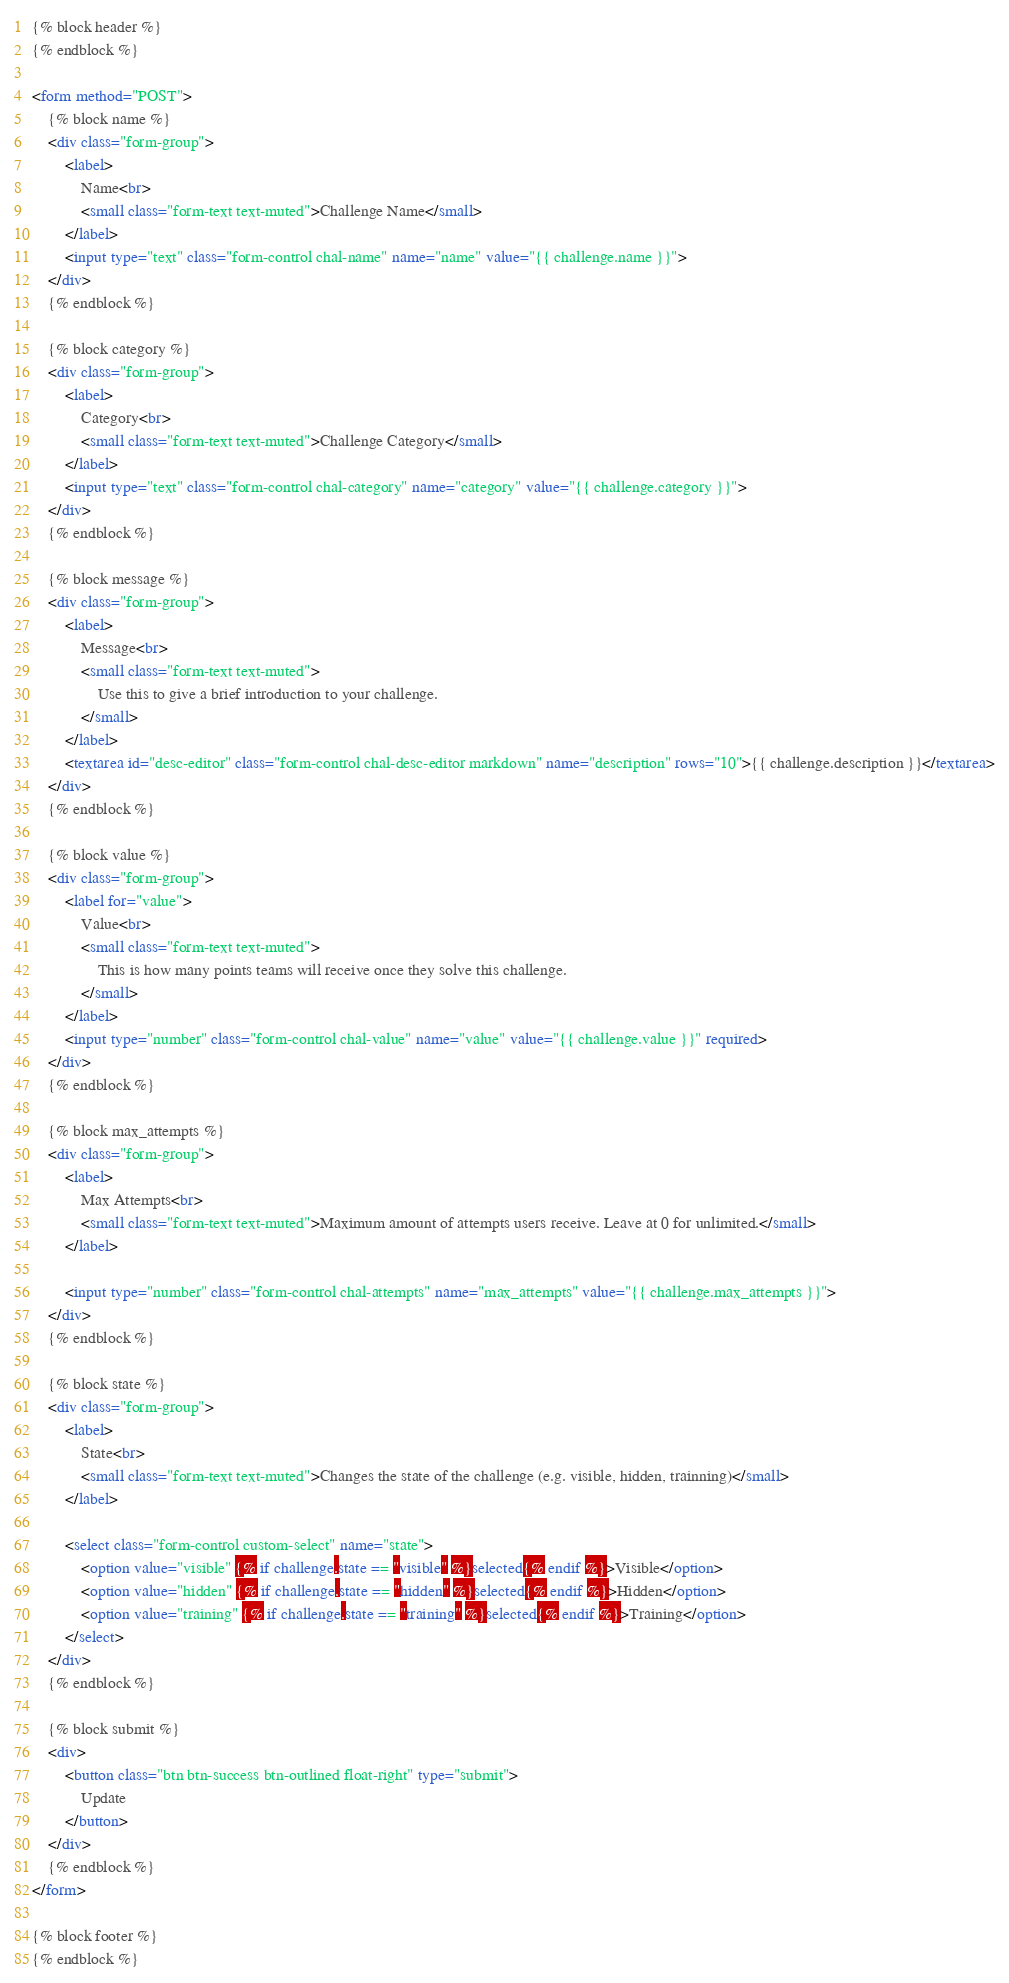Convert code to text. <code><loc_0><loc_0><loc_500><loc_500><_HTML_>{% block header %}
{% endblock %}

<form method="POST">
	{% block name %}
	<div class="form-group">
		<label>
			Name<br>
			<small class="form-text text-muted">Challenge Name</small>
		</label>
		<input type="text" class="form-control chal-name" name="name" value="{{ challenge.name }}">
	</div>
	{% endblock %}

	{% block category %}
	<div class="form-group">
		<label>
			Category<br>
			<small class="form-text text-muted">Challenge Category</small>
		</label>
		<input type="text" class="form-control chal-category" name="category" value="{{ challenge.category }}">
	</div>
	{% endblock %}

	{% block message %}
	<div class="form-group">
		<label>
			Message<br>
			<small class="form-text text-muted">
				Use this to give a brief introduction to your challenge.
			</small>
		</label>
		<textarea id="desc-editor" class="form-control chal-desc-editor markdown" name="description" rows="10">{{ challenge.description }}</textarea>
	</div>
	{% endblock %}

	{% block value %}
	<div class="form-group">
		<label for="value">
			Value<br>
			<small class="form-text text-muted">
				This is how many points teams will receive once they solve this challenge.
			</small>
		</label>
		<input type="number" class="form-control chal-value" name="value" value="{{ challenge.value }}" required>
	</div>
	{% endblock %}

	{% block max_attempts %}
	<div class="form-group">
		<label>
			Max Attempts<br>
			<small class="form-text text-muted">Maximum amount of attempts users receive. Leave at 0 for unlimited.</small>
		</label>

		<input type="number" class="form-control chal-attempts" name="max_attempts" value="{{ challenge.max_attempts }}">
	</div>
	{% endblock %}

	{% block state %}
	<div class="form-group">
		<label>
			State<br>
			<small class="form-text text-muted">Changes the state of the challenge (e.g. visible, hidden, trainning)</small>
		</label>

		<select class="form-control custom-select" name="state">
			<option value="visible" {% if challenge.state == "visible" %}selected{% endif %}>Visible</option>
			<option value="hidden" {% if challenge.state == "hidden" %}selected{% endif %}>Hidden</option>
			<option value="training" {% if challenge.state == "training" %}selected{% endif %}>Training</option>
		</select>
	</div>
	{% endblock %}

	{% block submit %}
	<div>
		<button class="btn btn-success btn-outlined float-right" type="submit">
			Update
		</button>
	</div>
	{% endblock %}
</form>

{% block footer %}
{% endblock %}</code> 